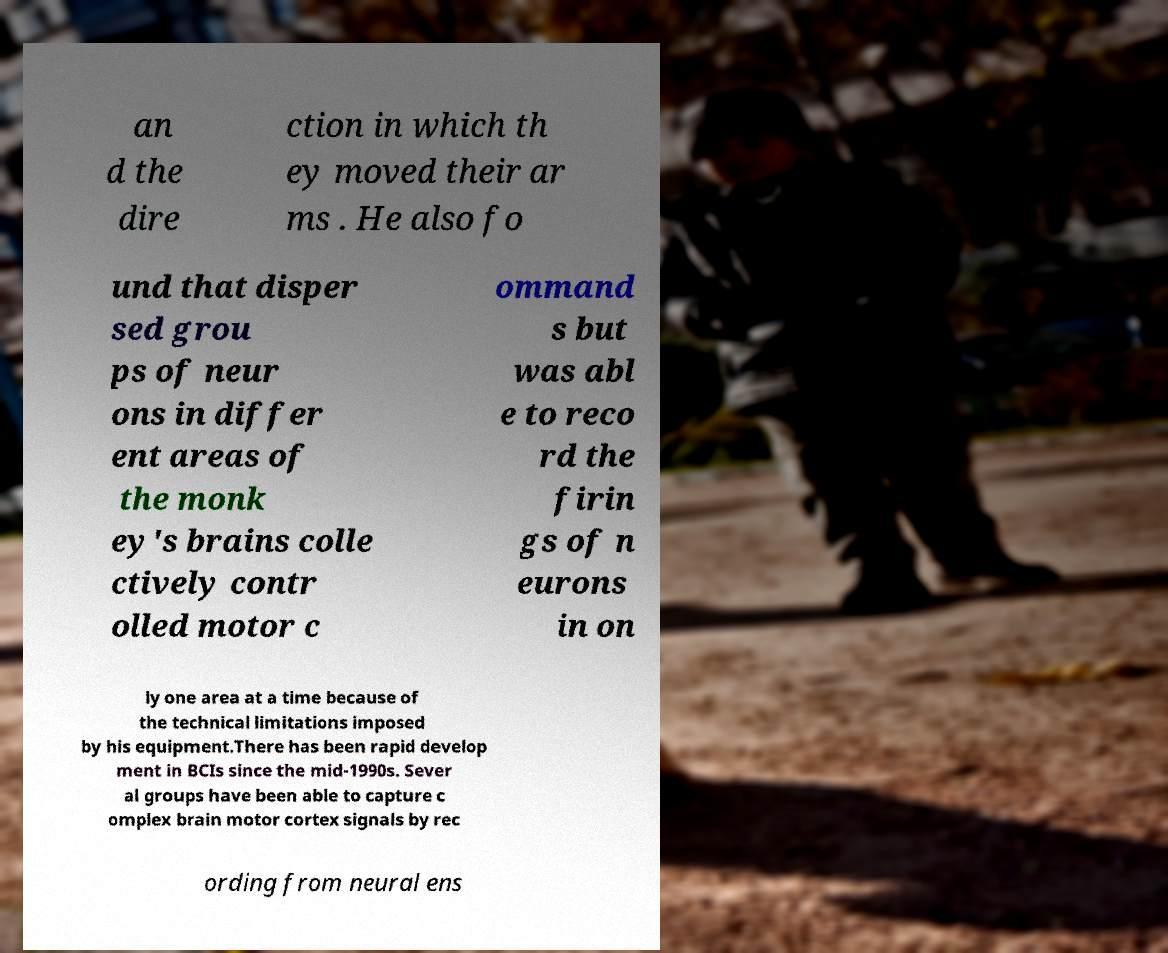There's text embedded in this image that I need extracted. Can you transcribe it verbatim? an d the dire ction in which th ey moved their ar ms . He also fo und that disper sed grou ps of neur ons in differ ent areas of the monk ey's brains colle ctively contr olled motor c ommand s but was abl e to reco rd the firin gs of n eurons in on ly one area at a time because of the technical limitations imposed by his equipment.There has been rapid develop ment in BCIs since the mid-1990s. Sever al groups have been able to capture c omplex brain motor cortex signals by rec ording from neural ens 